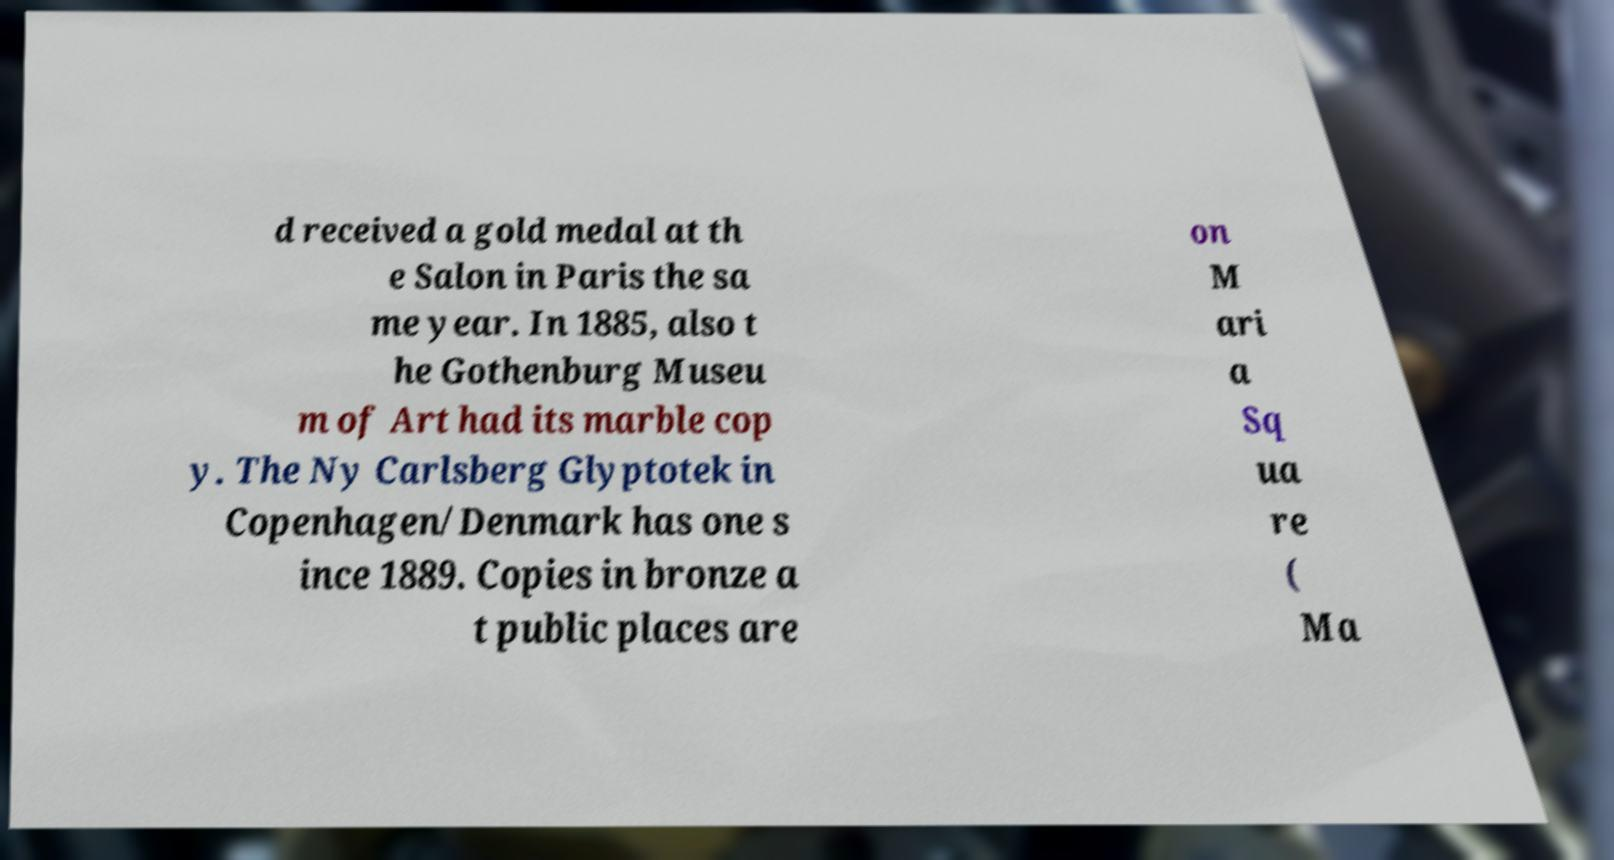Please read and relay the text visible in this image. What does it say? d received a gold medal at th e Salon in Paris the sa me year. In 1885, also t he Gothenburg Museu m of Art had its marble cop y. The Ny Carlsberg Glyptotek in Copenhagen/Denmark has one s ince 1889. Copies in bronze a t public places are on M ari a Sq ua re ( Ma 